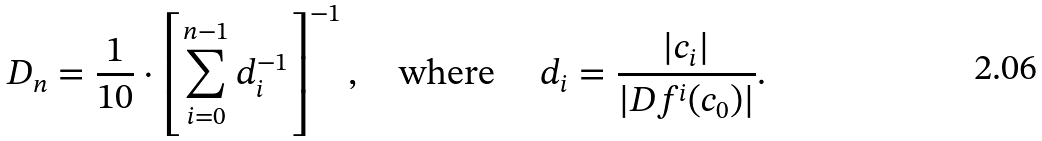Convert formula to latex. <formula><loc_0><loc_0><loc_500><loc_500>D _ { n } = \frac { 1 } { 1 0 } \cdot \left [ \sum _ { i = 0 } ^ { n - 1 } d _ { i } ^ { - 1 } \right ] ^ { - 1 } , \quad \text {where} \quad \ d _ { i } = \frac { | c _ { i } | } { | D f ^ { i } ( c _ { 0 } ) | } .</formula> 